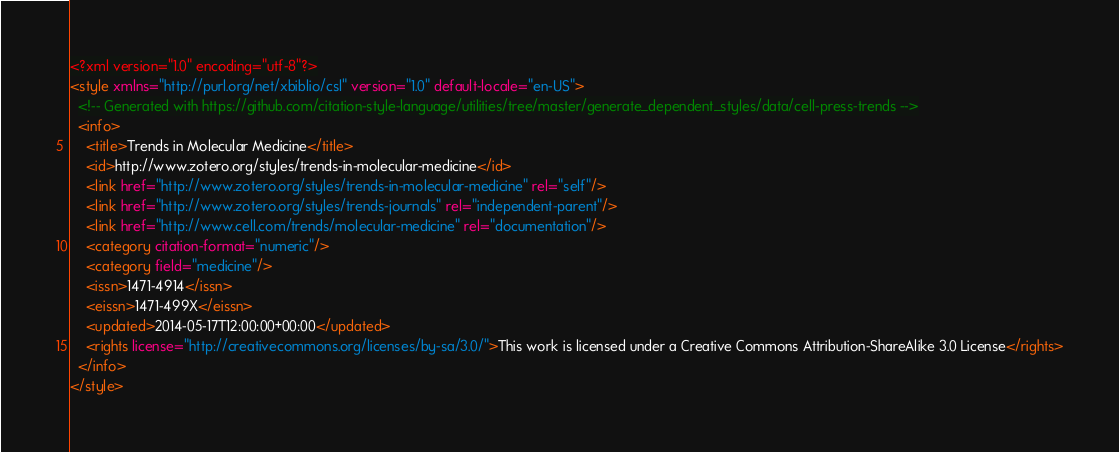Convert code to text. <code><loc_0><loc_0><loc_500><loc_500><_XML_><?xml version="1.0" encoding="utf-8"?>
<style xmlns="http://purl.org/net/xbiblio/csl" version="1.0" default-locale="en-US">
  <!-- Generated with https://github.com/citation-style-language/utilities/tree/master/generate_dependent_styles/data/cell-press-trends -->
  <info>
    <title>Trends in Molecular Medicine</title>
    <id>http://www.zotero.org/styles/trends-in-molecular-medicine</id>
    <link href="http://www.zotero.org/styles/trends-in-molecular-medicine" rel="self"/>
    <link href="http://www.zotero.org/styles/trends-journals" rel="independent-parent"/>
    <link href="http://www.cell.com/trends/molecular-medicine" rel="documentation"/>
    <category citation-format="numeric"/>
    <category field="medicine"/>
    <issn>1471-4914</issn>
    <eissn>1471-499X</eissn>
    <updated>2014-05-17T12:00:00+00:00</updated>
    <rights license="http://creativecommons.org/licenses/by-sa/3.0/">This work is licensed under a Creative Commons Attribution-ShareAlike 3.0 License</rights>
  </info>
</style>
</code> 